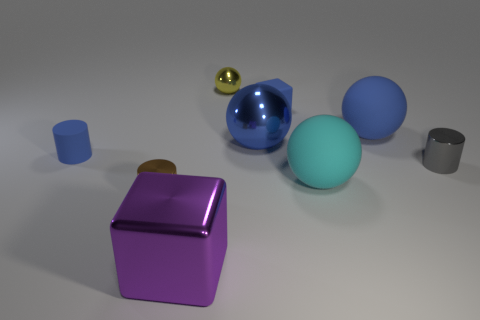What is the material of the block that is the same color as the rubber cylinder?
Offer a very short reply. Rubber. Is there another big ball that has the same color as the large metal ball?
Offer a very short reply. Yes. There is a small block; does it have the same color as the shiny sphere in front of the tiny yellow metal thing?
Provide a short and direct response. Yes. Are there more cylinders that are to the right of the brown object than large red metallic things?
Your answer should be very brief. Yes. There is a rubber sphere in front of the tiny cylinder on the right side of the small sphere; how many large metal things are in front of it?
Your answer should be very brief. 1. Do the tiny blue thing that is behind the big blue metallic ball and the big purple thing have the same shape?
Keep it short and to the point. Yes. There is a cube that is in front of the cyan rubber sphere; what material is it?
Offer a very short reply. Metal. There is a small metallic object that is both in front of the tiny sphere and on the right side of the purple metallic thing; what is its shape?
Make the answer very short. Cylinder. What material is the yellow sphere?
Give a very brief answer. Metal. What number of cubes are matte objects or big purple things?
Ensure brevity in your answer.  2. 